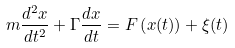<formula> <loc_0><loc_0><loc_500><loc_500>m \frac { d ^ { 2 } x } { d t ^ { 2 } } + \Gamma \frac { d x } { d t } = F \left ( x ( t ) \right ) + \xi ( t )</formula> 